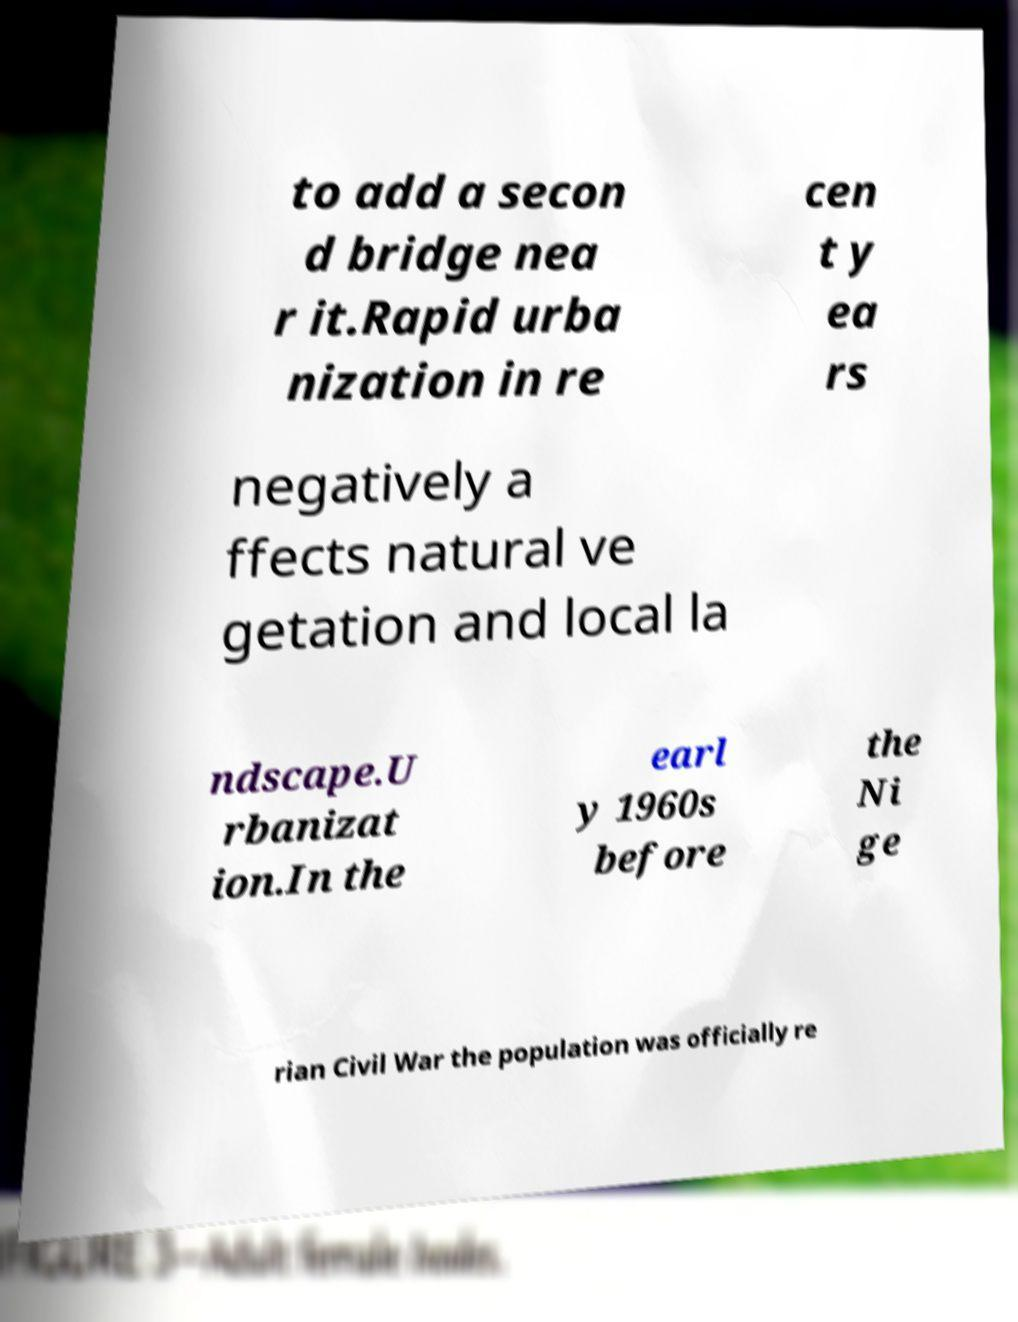Please identify and transcribe the text found in this image. to add a secon d bridge nea r it.Rapid urba nization in re cen t y ea rs negatively a ffects natural ve getation and local la ndscape.U rbanizat ion.In the earl y 1960s before the Ni ge rian Civil War the population was officially re 